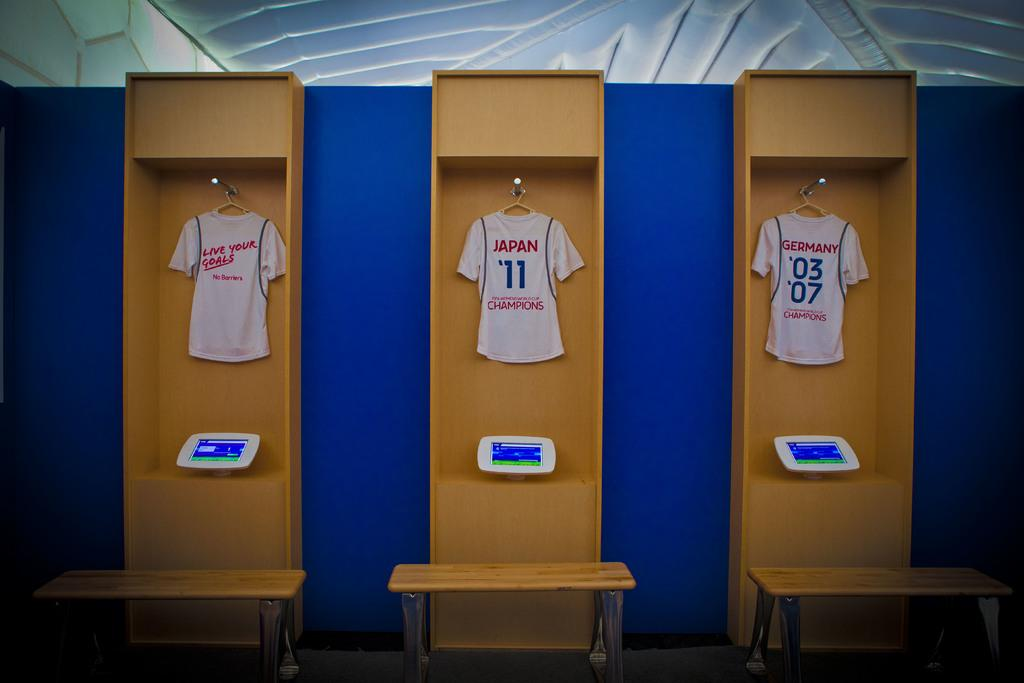<image>
Provide a brief description of the given image. three jerseys are jung up from different countries 